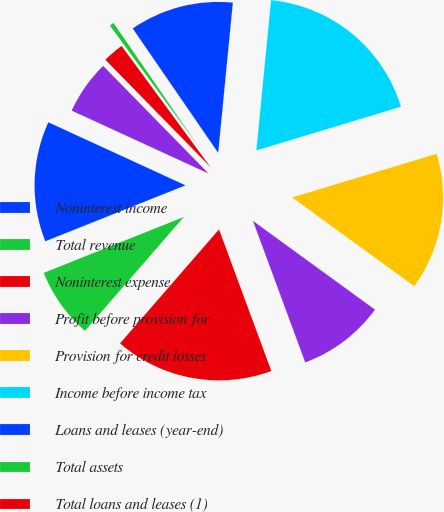<chart> <loc_0><loc_0><loc_500><loc_500><pie_chart><fcel>Noninterest income<fcel>Total revenue<fcel>Noninterest expense<fcel>Profit before provision for<fcel>Provision for credit losses<fcel>Income before income tax<fcel>Loans and leases (year-end)<fcel>Total assets<fcel>Total loans and leases (1)<fcel>Deposits<nl><fcel>12.9%<fcel>7.58%<fcel>17.01%<fcel>9.36%<fcel>14.68%<fcel>18.78%<fcel>11.13%<fcel>0.49%<fcel>2.26%<fcel>5.81%<nl></chart> 